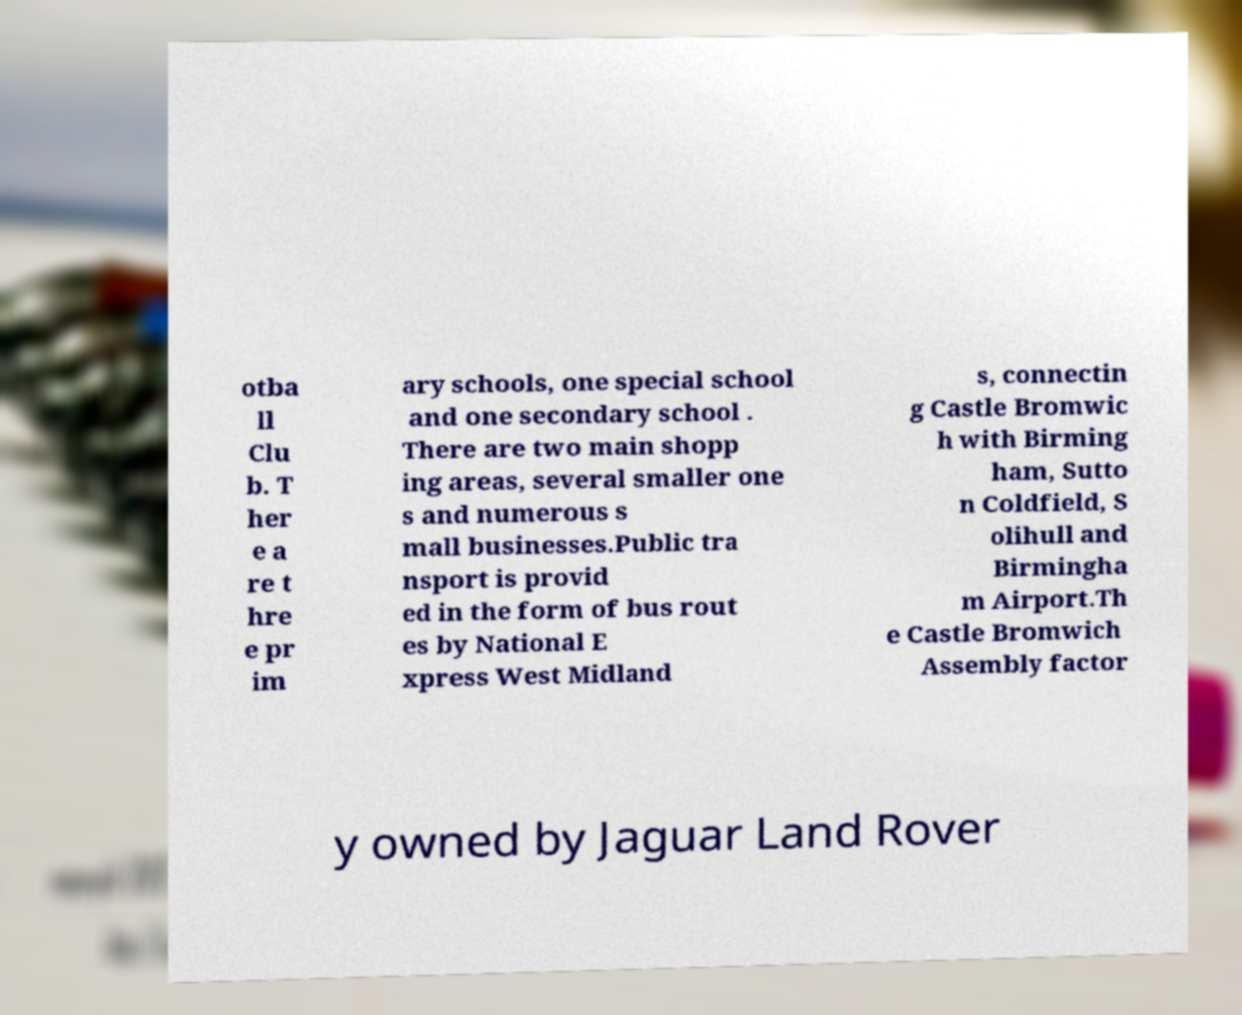Could you assist in decoding the text presented in this image and type it out clearly? otba ll Clu b. T her e a re t hre e pr im ary schools, one special school and one secondary school . There are two main shopp ing areas, several smaller one s and numerous s mall businesses.Public tra nsport is provid ed in the form of bus rout es by National E xpress West Midland s, connectin g Castle Bromwic h with Birming ham, Sutto n Coldfield, S olihull and Birmingha m Airport.Th e Castle Bromwich Assembly factor y owned by Jaguar Land Rover 